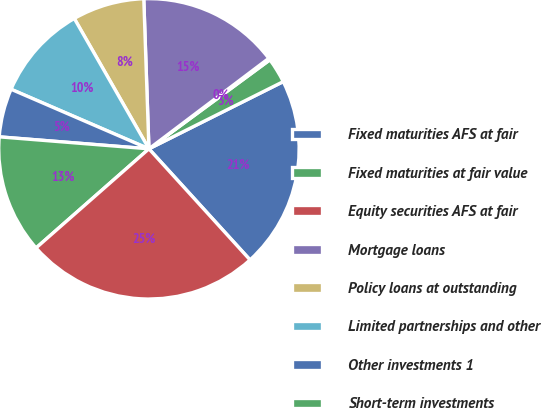Convert chart. <chart><loc_0><loc_0><loc_500><loc_500><pie_chart><fcel>Fixed maturities AFS at fair<fcel>Fixed maturities at fair value<fcel>Equity securities AFS at fair<fcel>Mortgage loans<fcel>Policy loans at outstanding<fcel>Limited partnerships and other<fcel>Other investments 1<fcel>Short-term investments<fcel>Total investments excluding<nl><fcel>20.63%<fcel>2.71%<fcel>0.2%<fcel>15.25%<fcel>7.73%<fcel>10.23%<fcel>5.22%<fcel>12.74%<fcel>25.28%<nl></chart> 